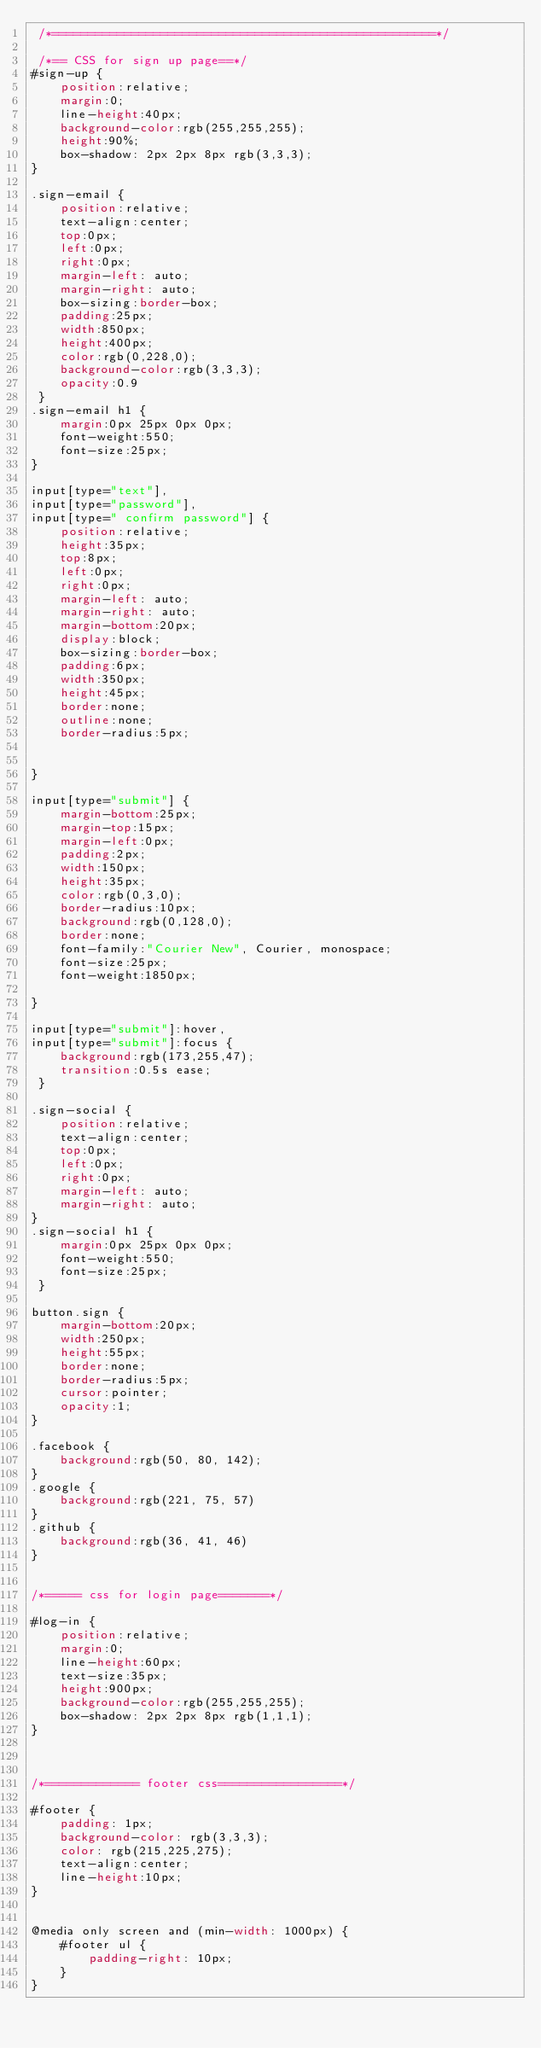<code> <loc_0><loc_0><loc_500><loc_500><_CSS_> /*=====================================================*/

 /*== CSS for sign up page==*/
#sign-up {
    position:relative;
    margin:0;
    line-height:40px;
    background-color:rgb(255,255,255);
    height:90%;
    box-shadow: 2px 2px 8px rgb(3,3,3);
}

.sign-email {
    position:relative;
    text-align:center;
    top:0px;
    left:0px;
    right:0px;
    margin-left: auto;
    margin-right: auto;
    box-sizing:border-box;
    padding:25px;
    width:850px;
    height:400px;
    color:rgb(0,228,0);
    background-color:rgb(3,3,3);
    opacity:0.9
 }
.sign-email h1 {
    margin:0px 25px 0px 0px;
    font-weight:550;
    font-size:25px;
}

input[type="text"],
input[type="password"],
input[type=" confirm password"] {
    position:relative;
    height:35px;
    top:8px;
    left:0px;
    right:0px;
    margin-left: auto;
    margin-right: auto;
    margin-bottom:20px;
    display:block;
    box-sizing:border-box;
    padding:6px;
    width:350px;
    height:45px;
    border:none;
    outline:none;
    border-radius:5px;


}

input[type="submit"] {
    margin-bottom:25px;
    margin-top:15px;
    margin-left:0px;
    padding:2px;
    width:150px;
    height:35px;
    color:rgb(0,3,0);
    border-radius:10px;
    background:rgb(0,128,0);
    border:none;
    font-family:"Courier New", Courier, monospace;
    font-size:25px;
    font-weight:1850px;

}

input[type="submit"]:hover,
input[type="submit"]:focus {
    background:rgb(173,255,47);
    transition:0.5s ease;
 }

.sign-social {
    position:relative;
    text-align:center;
    top:0px;
    left:0px;
    right:0px;
    margin-left: auto;
    margin-right: auto;
}
.sign-social h1 {
    margin:0px 25px 0px 0px;
    font-weight:550;
    font-size:25px;
 }

button.sign {
    margin-bottom:20px;
    width:250px;
    height:55px;
    border:none;
    border-radius:5px;
    cursor:pointer;
    opacity:1;
}

.facebook {
    background:rgb(50, 80, 142);
}
.google {
    background:rgb(221, 75, 57)
}
.github {
    background:rgb(36, 41, 46)
}


/*===== css for login page=======*/

#log-in {
    position:relative;
    margin:0;
    line-height:60px;
    text-size:35px;
    height:900px;
    background-color:rgb(255,255,255);
    box-shadow: 2px 2px 8px rgb(1,1,1);
}



/*============= footer css=================*/

#footer {
    padding: 1px;
    background-color: rgb(3,3,3);
    color: rgb(215,225,275);
    text-align:center;
    line-height:10px;
}


@media only screen and (min-width: 1000px) {
    #footer ul {
        padding-right: 10px;
    }
}</code> 